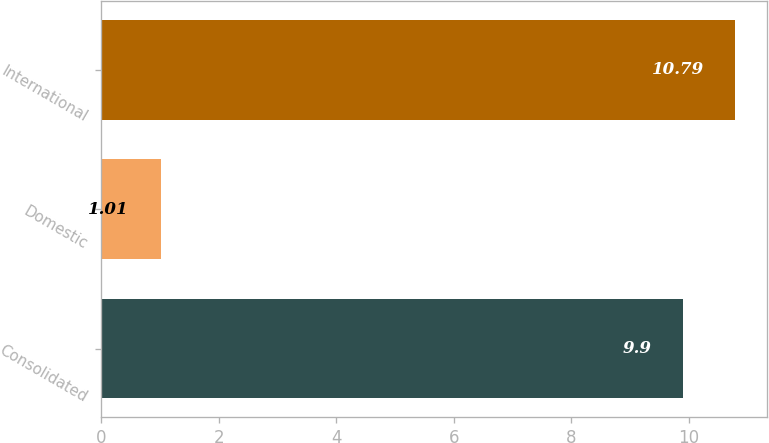Convert chart to OTSL. <chart><loc_0><loc_0><loc_500><loc_500><bar_chart><fcel>Consolidated<fcel>Domestic<fcel>International<nl><fcel>9.9<fcel>1.01<fcel>10.79<nl></chart> 